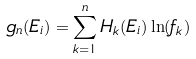<formula> <loc_0><loc_0><loc_500><loc_500>g _ { n } ( E _ { i } ) = \sum _ { k = 1 } ^ { n } H _ { k } ( E _ { i } ) \ln ( f _ { k } )</formula> 